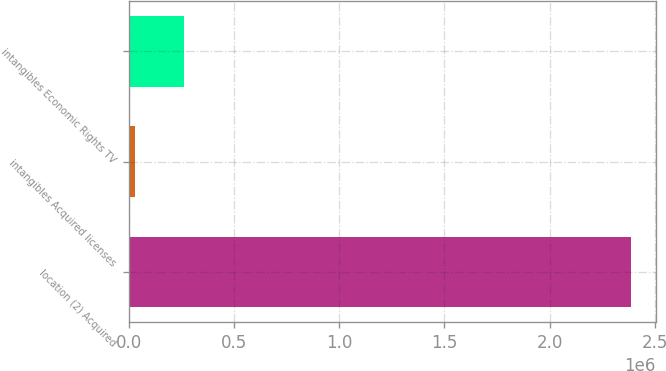<chart> <loc_0><loc_0><loc_500><loc_500><bar_chart><fcel>location (2) Acquired<fcel>intangibles Acquired licenses<fcel>intangibles Economic Rights TV<nl><fcel>2.38718e+06<fcel>25949<fcel>262072<nl></chart> 